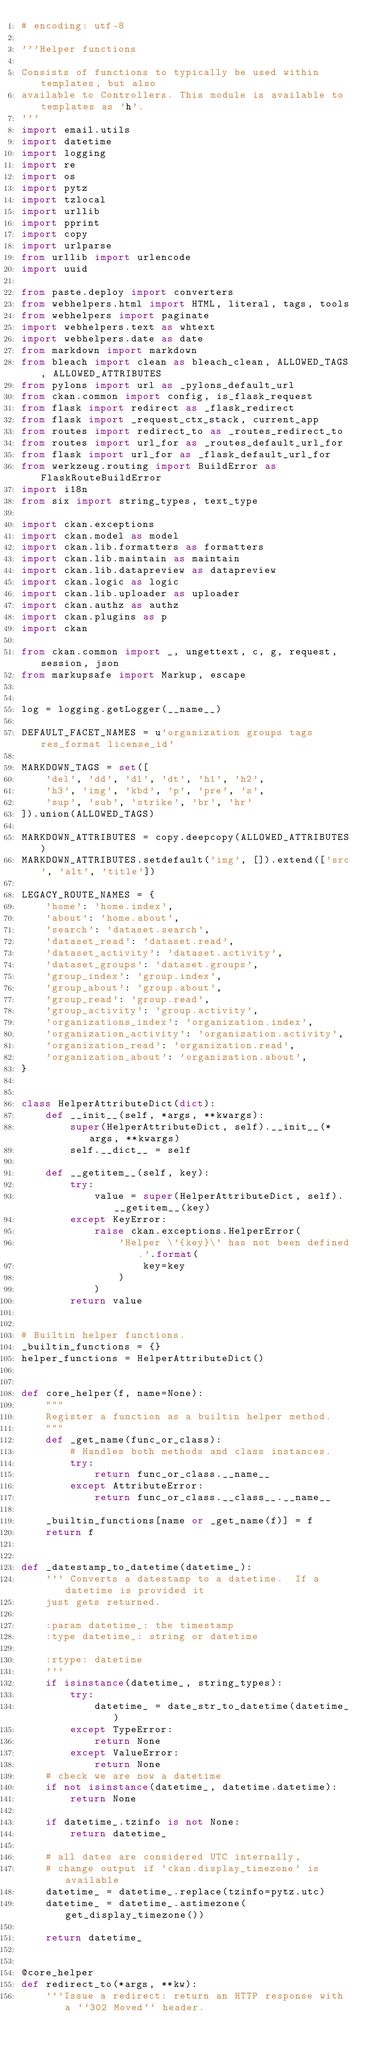Convert code to text. <code><loc_0><loc_0><loc_500><loc_500><_Python_># encoding: utf-8

'''Helper functions

Consists of functions to typically be used within templates, but also
available to Controllers. This module is available to templates as 'h'.
'''
import email.utils
import datetime
import logging
import re
import os
import pytz
import tzlocal
import urllib
import pprint
import copy
import urlparse
from urllib import urlencode
import uuid

from paste.deploy import converters
from webhelpers.html import HTML, literal, tags, tools
from webhelpers import paginate
import webhelpers.text as whtext
import webhelpers.date as date
from markdown import markdown
from bleach import clean as bleach_clean, ALLOWED_TAGS, ALLOWED_ATTRIBUTES
from pylons import url as _pylons_default_url
from ckan.common import config, is_flask_request
from flask import redirect as _flask_redirect
from flask import _request_ctx_stack, current_app
from routes import redirect_to as _routes_redirect_to
from routes import url_for as _routes_default_url_for
from flask import url_for as _flask_default_url_for
from werkzeug.routing import BuildError as FlaskRouteBuildError
import i18n
from six import string_types, text_type

import ckan.exceptions
import ckan.model as model
import ckan.lib.formatters as formatters
import ckan.lib.maintain as maintain
import ckan.lib.datapreview as datapreview
import ckan.logic as logic
import ckan.lib.uploader as uploader
import ckan.authz as authz
import ckan.plugins as p
import ckan

from ckan.common import _, ungettext, c, g, request, session, json
from markupsafe import Markup, escape


log = logging.getLogger(__name__)

DEFAULT_FACET_NAMES = u'organization groups tags res_format license_id'

MARKDOWN_TAGS = set([
    'del', 'dd', 'dl', 'dt', 'h1', 'h2',
    'h3', 'img', 'kbd', 'p', 'pre', 's',
    'sup', 'sub', 'strike', 'br', 'hr'
]).union(ALLOWED_TAGS)

MARKDOWN_ATTRIBUTES = copy.deepcopy(ALLOWED_ATTRIBUTES)
MARKDOWN_ATTRIBUTES.setdefault('img', []).extend(['src', 'alt', 'title'])

LEGACY_ROUTE_NAMES = {
    'home': 'home.index',
    'about': 'home.about',
    'search': 'dataset.search',
    'dataset_read': 'dataset.read',
    'dataset_activity': 'dataset.activity',
    'dataset_groups': 'dataset.groups',
    'group_index': 'group.index',
    'group_about': 'group.about',
    'group_read': 'group.read',
    'group_activity': 'group.activity',
    'organizations_index': 'organization.index',
    'organization_activity': 'organization.activity',
    'organization_read': 'organization.read',
    'organization_about': 'organization.about',
}


class HelperAttributeDict(dict):
    def __init__(self, *args, **kwargs):
        super(HelperAttributeDict, self).__init__(*args, **kwargs)
        self.__dict__ = self

    def __getitem__(self, key):
        try:
            value = super(HelperAttributeDict, self).__getitem__(key)
        except KeyError:
            raise ckan.exceptions.HelperError(
                'Helper \'{key}\' has not been defined.'.format(
                    key=key
                )
            )
        return value


# Builtin helper functions.
_builtin_functions = {}
helper_functions = HelperAttributeDict()


def core_helper(f, name=None):
    """
    Register a function as a builtin helper method.
    """
    def _get_name(func_or_class):
        # Handles both methods and class instances.
        try:
            return func_or_class.__name__
        except AttributeError:
            return func_or_class.__class__.__name__

    _builtin_functions[name or _get_name(f)] = f
    return f


def _datestamp_to_datetime(datetime_):
    ''' Converts a datestamp to a datetime.  If a datetime is provided it
    just gets returned.

    :param datetime_: the timestamp
    :type datetime_: string or datetime

    :rtype: datetime
    '''
    if isinstance(datetime_, string_types):
        try:
            datetime_ = date_str_to_datetime(datetime_)
        except TypeError:
            return None
        except ValueError:
            return None
    # check we are now a datetime
    if not isinstance(datetime_, datetime.datetime):
        return None

    if datetime_.tzinfo is not None:
        return datetime_

    # all dates are considered UTC internally,
    # change output if `ckan.display_timezone` is available
    datetime_ = datetime_.replace(tzinfo=pytz.utc)
    datetime_ = datetime_.astimezone(get_display_timezone())

    return datetime_


@core_helper
def redirect_to(*args, **kw):
    '''Issue a redirect: return an HTTP response with a ``302 Moved`` header.
</code> 